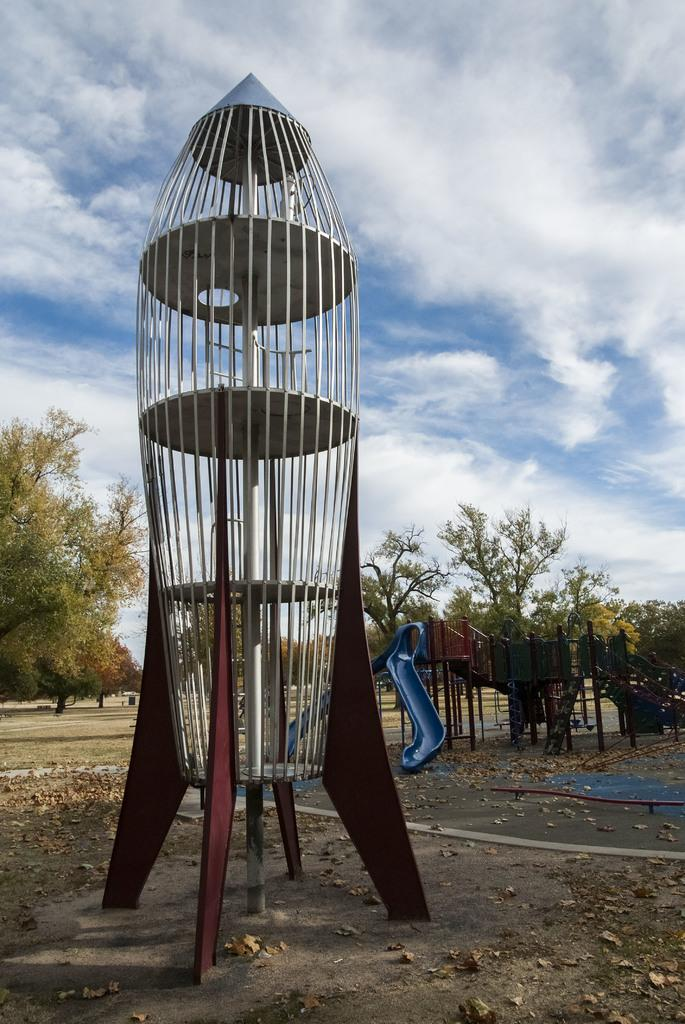What type of objects can be seen on the land in the image? There are playing objects on the land in the image. What other natural elements are present on the land? There are trees on the land. What is visible at the top of the image? The sky is visible at the top of the image. What can be observed in the sky? There are clouds in the sky. What type of jewel is hidden in the grass in the image? There is no jewel or grass present in the image. What type of weather can be observed in the image? The presence of clouds in the sky suggests that the weather might be partly cloudy, but the image does not provide enough information to determine the exact weather conditions. 